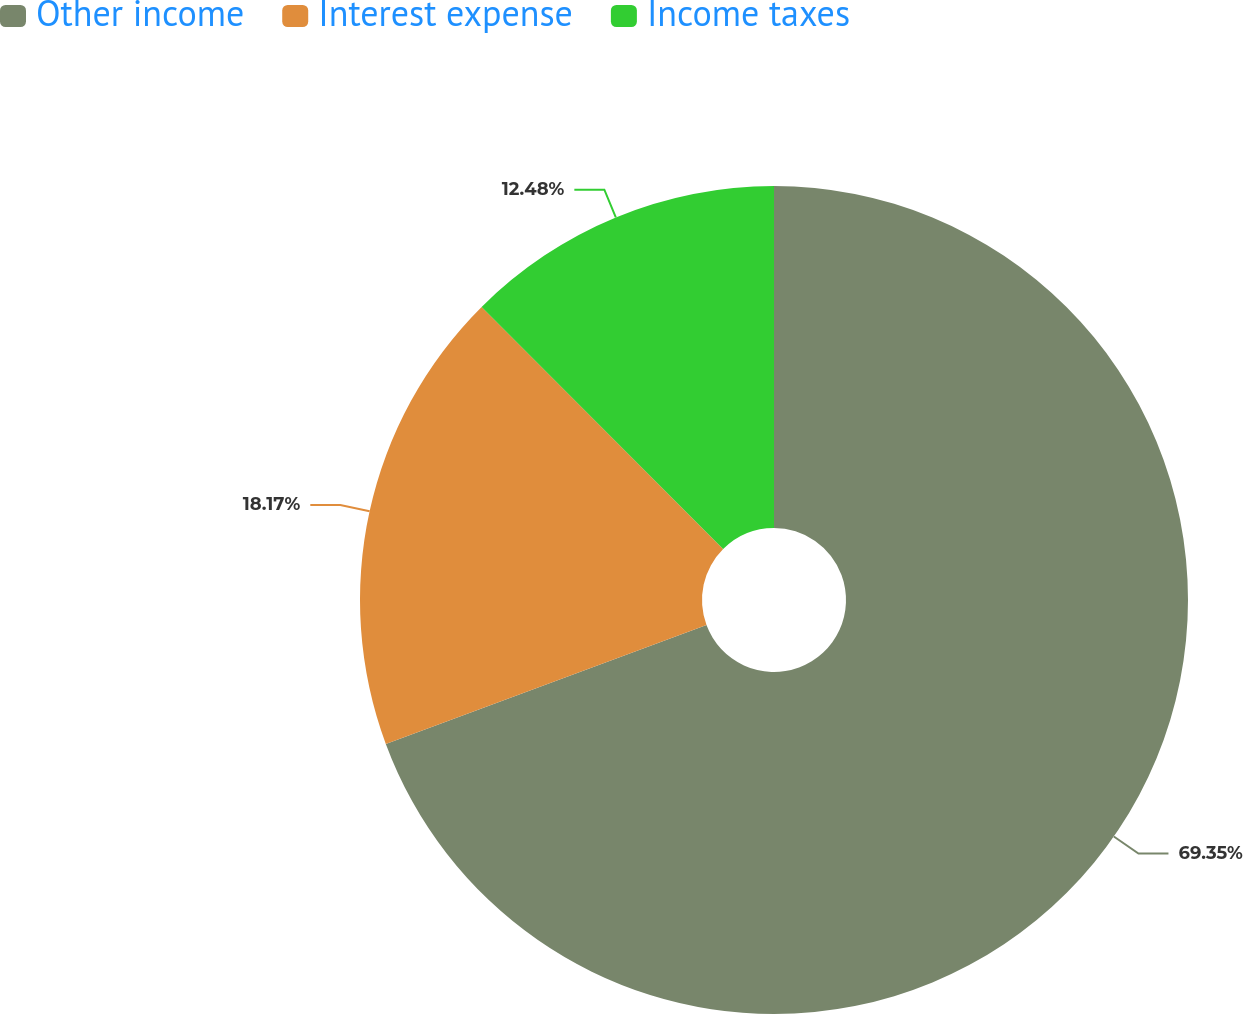Convert chart. <chart><loc_0><loc_0><loc_500><loc_500><pie_chart><fcel>Other income<fcel>Interest expense<fcel>Income taxes<nl><fcel>69.35%<fcel>18.17%<fcel>12.48%<nl></chart> 